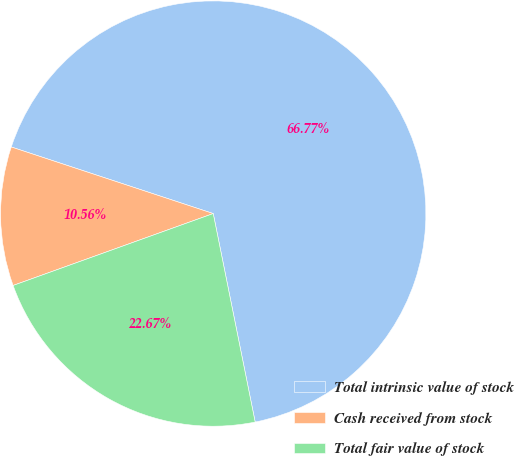Convert chart to OTSL. <chart><loc_0><loc_0><loc_500><loc_500><pie_chart><fcel>Total intrinsic value of stock<fcel>Cash received from stock<fcel>Total fair value of stock<nl><fcel>66.77%<fcel>10.56%<fcel>22.67%<nl></chart> 